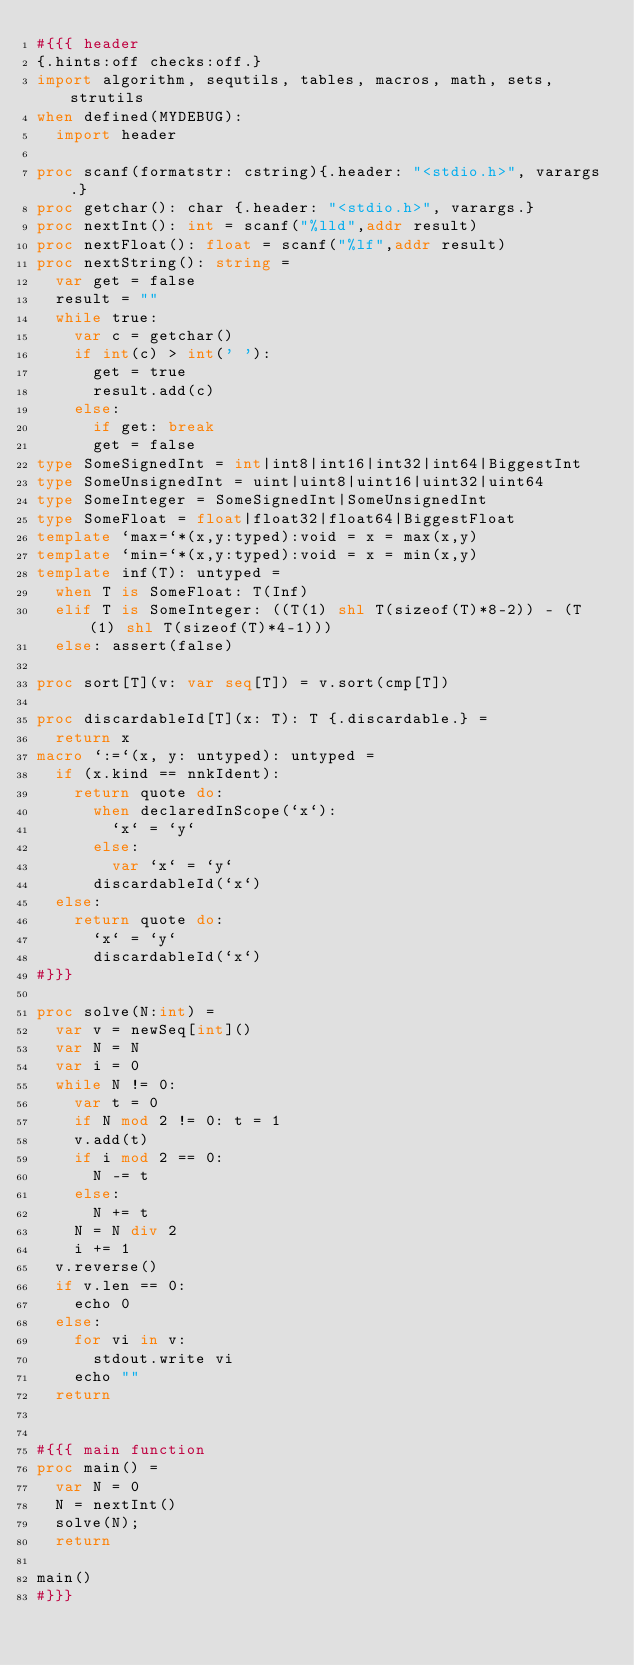Convert code to text. <code><loc_0><loc_0><loc_500><loc_500><_Nim_>#{{{ header
{.hints:off checks:off.}
import algorithm, sequtils, tables, macros, math, sets, strutils
when defined(MYDEBUG):
  import header

proc scanf(formatstr: cstring){.header: "<stdio.h>", varargs.}
proc getchar(): char {.header: "<stdio.h>", varargs.}
proc nextInt(): int = scanf("%lld",addr result)
proc nextFloat(): float = scanf("%lf",addr result)
proc nextString(): string =
  var get = false
  result = ""
  while true:
    var c = getchar()
    if int(c) > int(' '):
      get = true
      result.add(c)
    else:
      if get: break
      get = false
type SomeSignedInt = int|int8|int16|int32|int64|BiggestInt
type SomeUnsignedInt = uint|uint8|uint16|uint32|uint64
type SomeInteger = SomeSignedInt|SomeUnsignedInt
type SomeFloat = float|float32|float64|BiggestFloat
template `max=`*(x,y:typed):void = x = max(x,y)
template `min=`*(x,y:typed):void = x = min(x,y)
template inf(T): untyped = 
  when T is SomeFloat: T(Inf)
  elif T is SomeInteger: ((T(1) shl T(sizeof(T)*8-2)) - (T(1) shl T(sizeof(T)*4-1)))
  else: assert(false)

proc sort[T](v: var seq[T]) = v.sort(cmp[T])

proc discardableId[T](x: T): T {.discardable.} =
  return x
macro `:=`(x, y: untyped): untyped =
  if (x.kind == nnkIdent):
    return quote do:
      when declaredInScope(`x`):
        `x` = `y`
      else:
        var `x` = `y`
      discardableId(`x`)
  else:
    return quote do:
      `x` = `y`
      discardableId(`x`)
#}}}

proc solve(N:int) =
  var v = newSeq[int]()
  var N = N
  var i = 0
  while N != 0:
    var t = 0
    if N mod 2 != 0: t = 1
    v.add(t)
    if i mod 2 == 0:
      N -= t
    else:
      N += t
    N = N div 2
    i += 1
  v.reverse()
  if v.len == 0:
    echo 0
  else:
    for vi in v:
      stdout.write vi
    echo ""
  return


#{{{ main function
proc main() =
  var N = 0
  N = nextInt()
  solve(N);
  return

main()
#}}}
</code> 